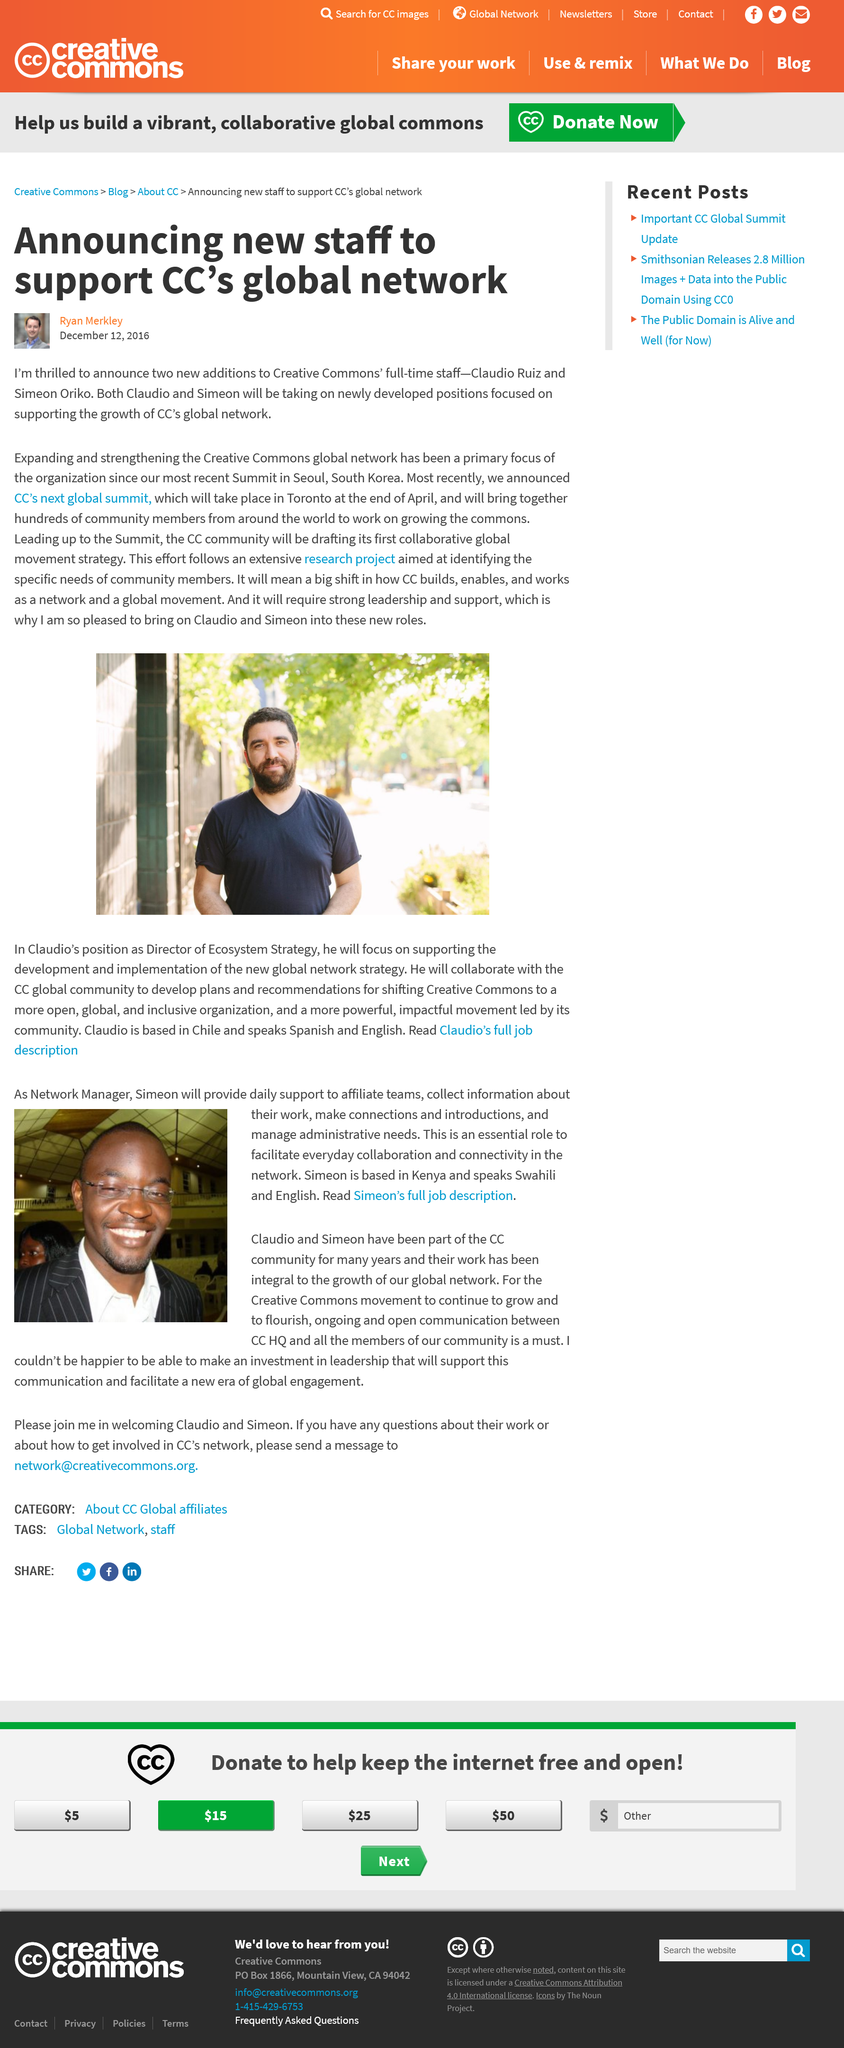List a handful of essential elements in this visual. Simeon is based in Kenya. It has been announced that the next global summit hosted by CC will be held in April. The man in the small portrait below the title is named Ryan Merkley. Simeon works for CC. What is Simeon's work title? It is Network Manager. 